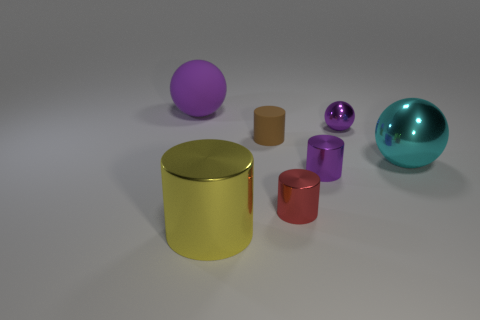What could be the possible uses for these objects? The objects appear to be simplistic and idealized representations, not actual products, but based on their shapes they could be conceptual stand-ins for containers, like the cylinders, or decorative items, like the spheres and ellipsoid. 